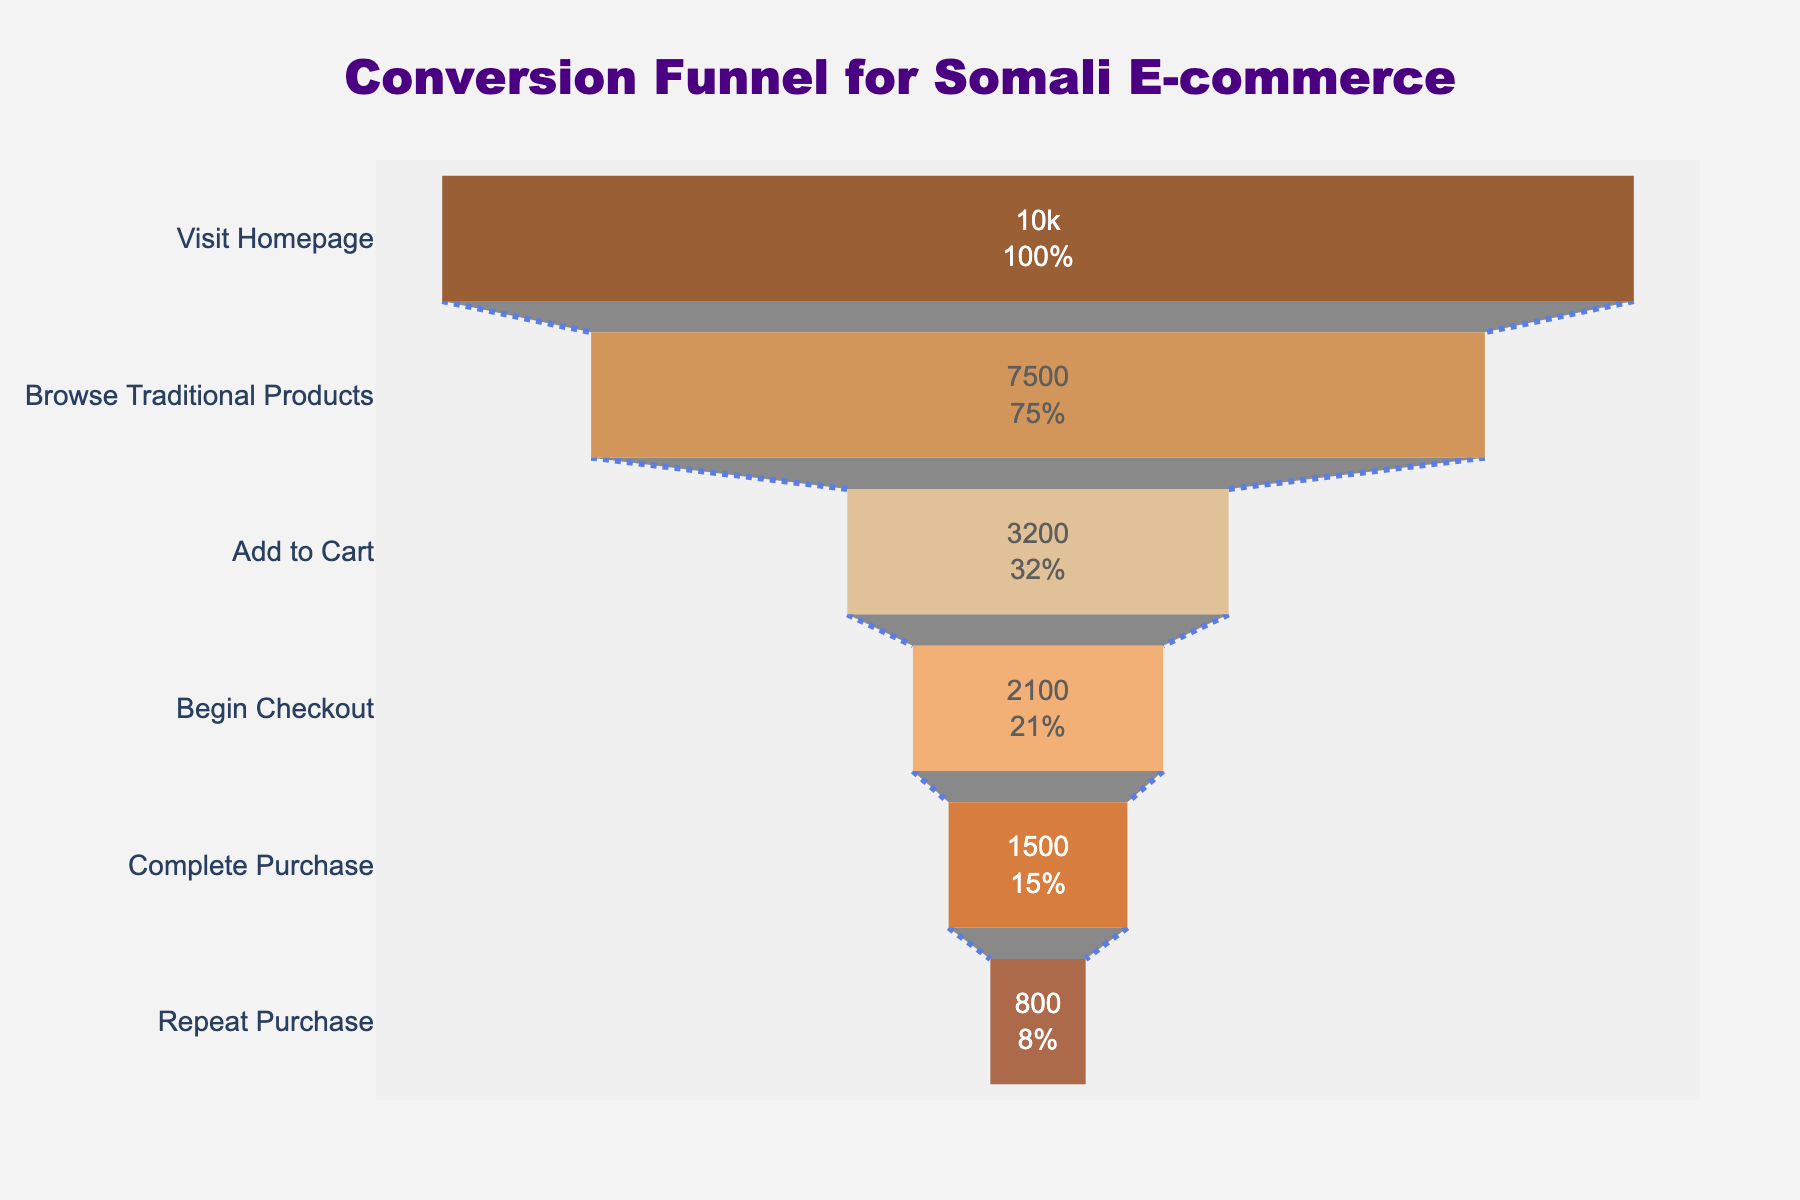What's the total number of users who visited the homepage? The total number of users who visited the homepage is directly taken from the first stage of the funnel chart.
Answer: 10,000 How many users completed a purchase? The number of users can be found in the 'Complete Purchase' stage in the funnel chart.
Answer: 1,500 What percentage of users who visited the homepage completed a purchase? Divide the number of users who completed a purchase by the number of users who visited the homepage and multiply by 100. (1500/10000) * 100 = 15%
Answer: 15% What is the ratio of users who browsed traditional products to those who added items to the cart? To find the ratio, divide the users who browsed traditional products by the users who added items to the cart: 7500/3200.
Answer: approximately 2.34 How many users progressed from beginning checkout to completing the purchase? Subtract the number of users who completed the purchase from those who began checkout: 2100 - 1500.
Answer: 600 What stage saw the highest drop-off in users? Identify the largest difference between stages: Visit Homepage (10000) to Browse Traditional Products (7500) is 10000 - 7500 = 2500 users.
Answer: Browse Traditional Products How many more users added items to the cart compared to those who completed purchases? Subtract the number of users who completed purchases from those who added items to the cart: 3200 - 1500.
Answer: 1,700 What is the percentage decrease from 'Add to Cart' to 'Begin Checkout'? Calculate the decrease: (Add to Cart - Begin Checkout) / Add to Cart * 100, which is ((3200 - 2100) / 3200) * 100 ≈ 34.38%.
Answer: 34.38% What is the average number of users in all stages? Sum all users in each stage and divide by the number of stages. (10000 + 7500 + 3200 + 2100 + 1500 + 800) / 6 = 4075
Answer: 4075 Which stage has the lowest number of users? Identify the lowest value in the 'Users' column: Repeat Purchase with 800 users.
Answer: Repeat Purchase 